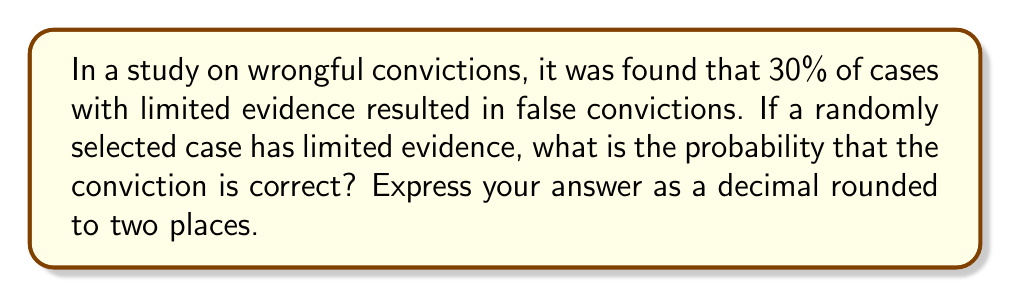Show me your answer to this math problem. Let's approach this step-by-step:

1) First, we need to understand what the question is asking. We're looking for the probability of a correct conviction given that the case has limited evidence.

2) We're given that 30% of cases with limited evidence result in false convictions. This means that:

   $P(\text{False Conviction} | \text{Limited Evidence}) = 0.30$

3) The probability of a correct conviction is the complement of the probability of a false conviction. In other words:

   $P(\text{Correct Conviction} | \text{Limited Evidence}) = 1 - P(\text{False Conviction} | \text{Limited Evidence})$

4) We can now calculate:

   $P(\text{Correct Conviction} | \text{Limited Evidence}) = 1 - 0.30 = 0.70$

5) Rounding to two decimal places:

   $P(\text{Correct Conviction} | \text{Limited Evidence}) \approx 0.70$

This result suggests that even with limited evidence, 70% of convictions are still correct. However, it's important to note that a 30% chance of wrongful conviction is alarmingly high and highlights significant issues in the criminal justice system when dealing with cases that have limited evidence.
Answer: 0.70 